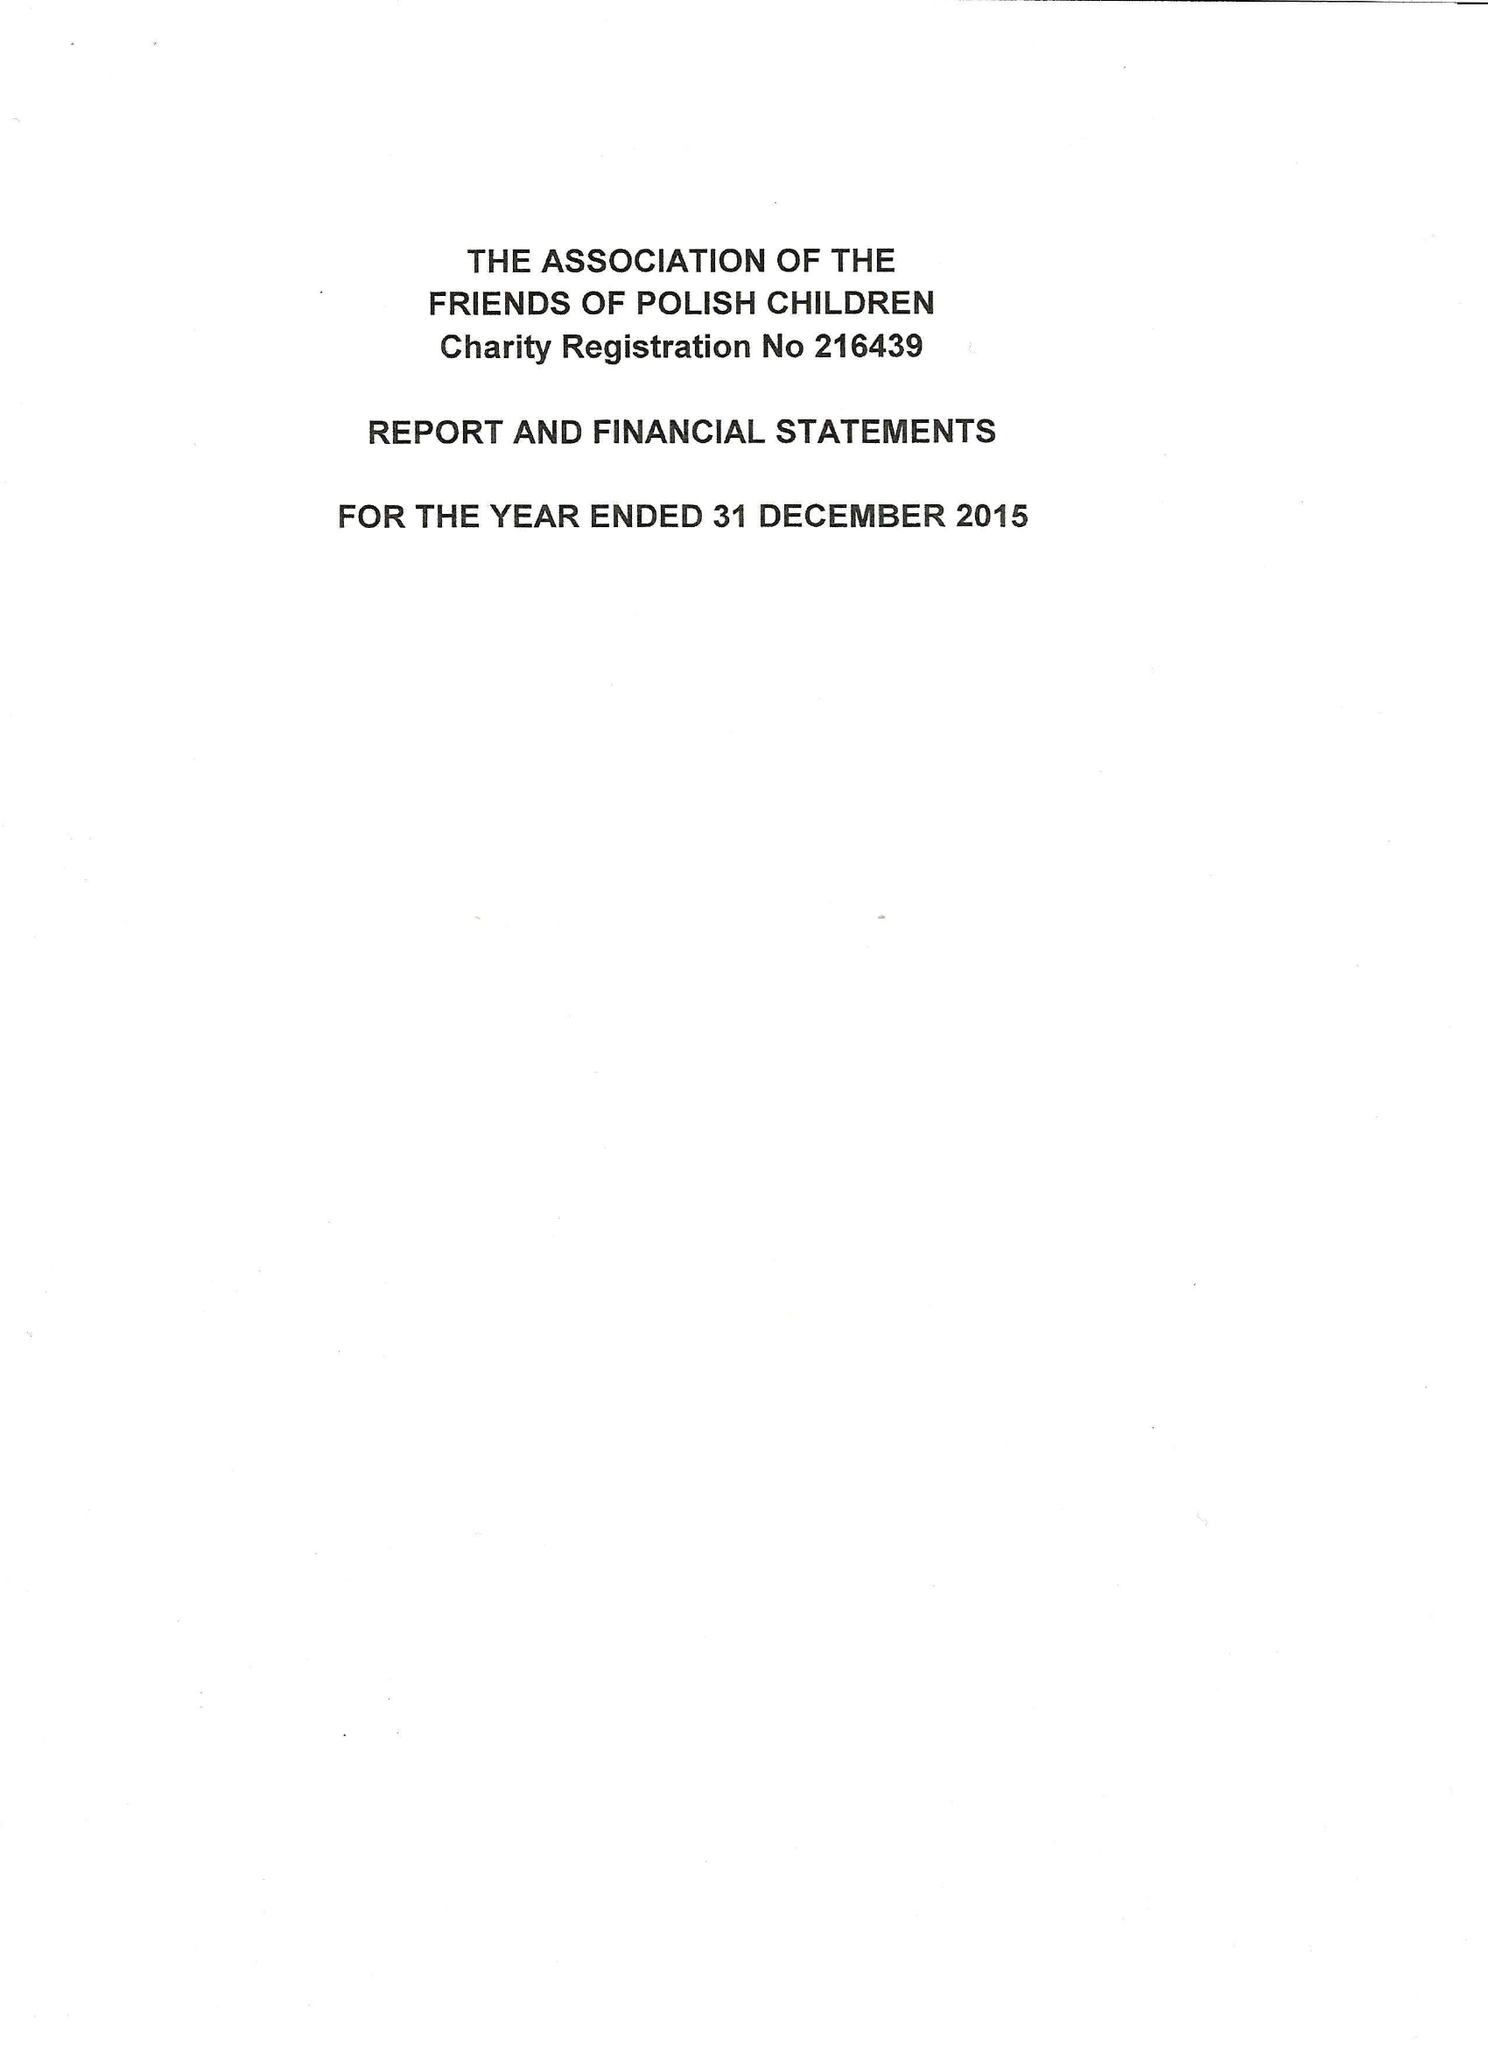What is the value for the charity_name?
Answer the question using a single word or phrase. The Association Of The Friends Of Polish Children 